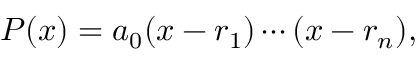Convert formula to latex. <formula><loc_0><loc_0><loc_500><loc_500>P ( x ) = a _ { 0 } ( x - r _ { 1 } ) \cdots ( x - r _ { n } ) ,</formula> 